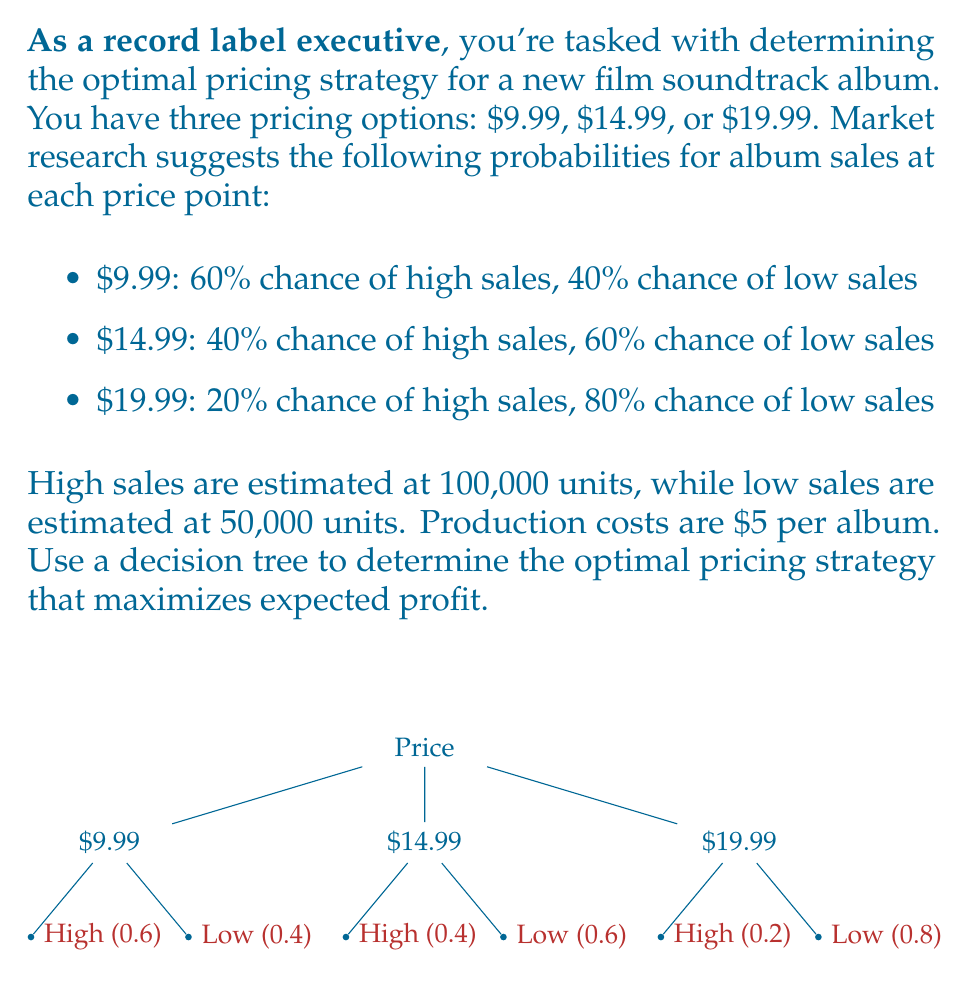What is the answer to this math problem? Let's solve this problem step-by-step using a decision tree approach:

1) First, calculate the profit per unit for each price point:
   - $9.99: $9.99 - $5 = $4.99 per unit
   - $14.99: $14.99 - $5 = $9.99 per unit
   - $19.99: $19.99 - $5 = $14.99 per unit

2) Now, calculate the expected profit for each pricing strategy:

   For $9.99:
   - High sales (60%): 100,000 * $4.99 = $499,000
   - Low sales (40%): 50,000 * $4.99 = $249,500
   Expected profit = (0.6 * $499,000) + (0.4 * $249,500) = $399,400

   For $14.99:
   - High sales (40%): 100,000 * $9.99 = $999,000
   - Low sales (60%): 50,000 * $9.99 = $499,500
   Expected profit = (0.4 * $999,000) + (0.6 * $499,500) = $699,600

   For $19.99:
   - High sales (20%): 100,000 * $14.99 = $1,499,000
   - Low sales (80%): 50,000 * $14.99 = $749,500
   Expected profit = (0.2 * $1,499,000) + (0.8 * $749,500) = $899,600

3) Compare the expected profits:
   $9.99: $399,400
   $14.99: $699,600
   $19.99: $899,600

4) The optimal pricing strategy is the one with the highest expected profit.

Therefore, the optimal pricing strategy is to price the album at $19.99, which yields an expected profit of $899,600.
Answer: $19.99 